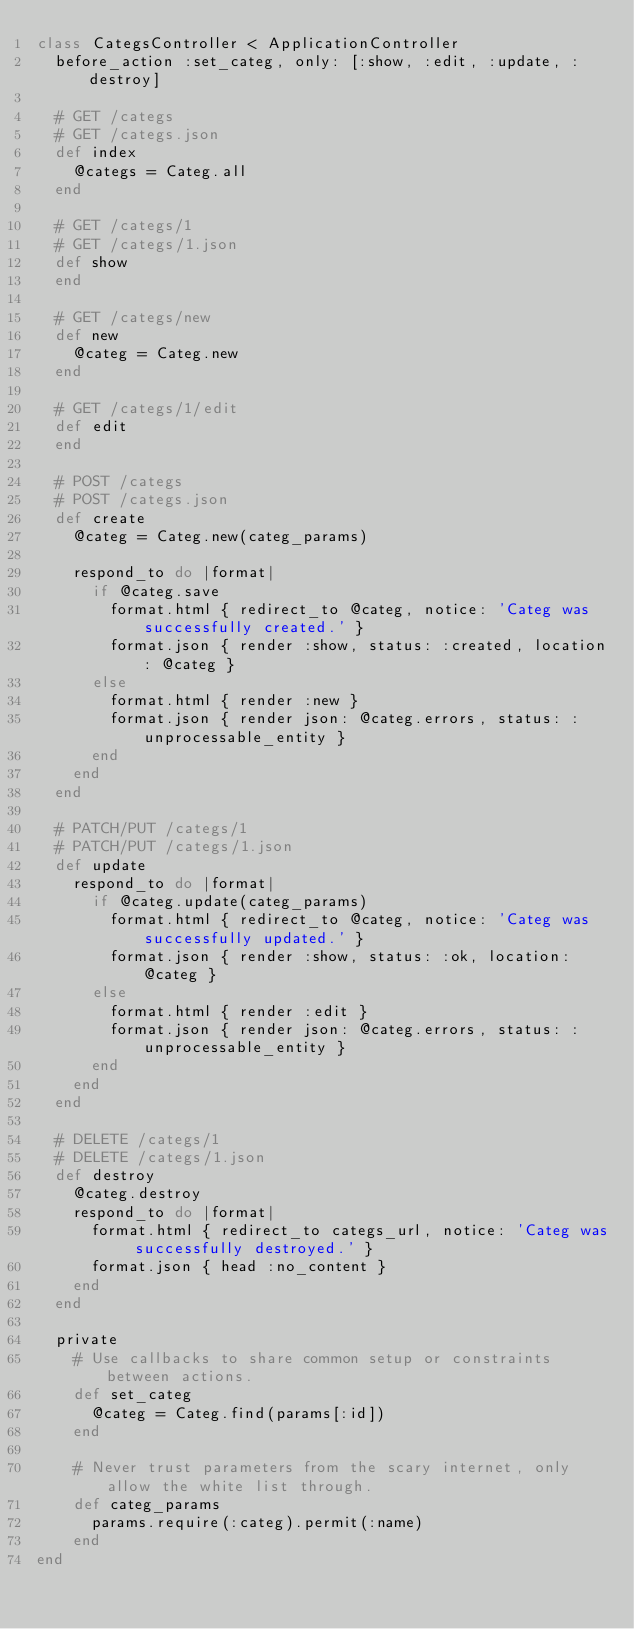Convert code to text. <code><loc_0><loc_0><loc_500><loc_500><_Ruby_>class CategsController < ApplicationController
  before_action :set_categ, only: [:show, :edit, :update, :destroy]

  # GET /categs
  # GET /categs.json
  def index
    @categs = Categ.all
  end

  # GET /categs/1
  # GET /categs/1.json
  def show
  end

  # GET /categs/new
  def new
    @categ = Categ.new
  end

  # GET /categs/1/edit
  def edit
  end

  # POST /categs
  # POST /categs.json
  def create
    @categ = Categ.new(categ_params)

    respond_to do |format|
      if @categ.save
        format.html { redirect_to @categ, notice: 'Categ was successfully created.' }
        format.json { render :show, status: :created, location: @categ }
      else
        format.html { render :new }
        format.json { render json: @categ.errors, status: :unprocessable_entity }
      end
    end
  end

  # PATCH/PUT /categs/1
  # PATCH/PUT /categs/1.json
  def update
    respond_to do |format|
      if @categ.update(categ_params)
        format.html { redirect_to @categ, notice: 'Categ was successfully updated.' }
        format.json { render :show, status: :ok, location: @categ }
      else
        format.html { render :edit }
        format.json { render json: @categ.errors, status: :unprocessable_entity }
      end
    end
  end

  # DELETE /categs/1
  # DELETE /categs/1.json
  def destroy
    @categ.destroy
    respond_to do |format|
      format.html { redirect_to categs_url, notice: 'Categ was successfully destroyed.' }
      format.json { head :no_content }
    end
  end

  private
    # Use callbacks to share common setup or constraints between actions.
    def set_categ
      @categ = Categ.find(params[:id])
    end

    # Never trust parameters from the scary internet, only allow the white list through.
    def categ_params
      params.require(:categ).permit(:name)
    end
end
</code> 